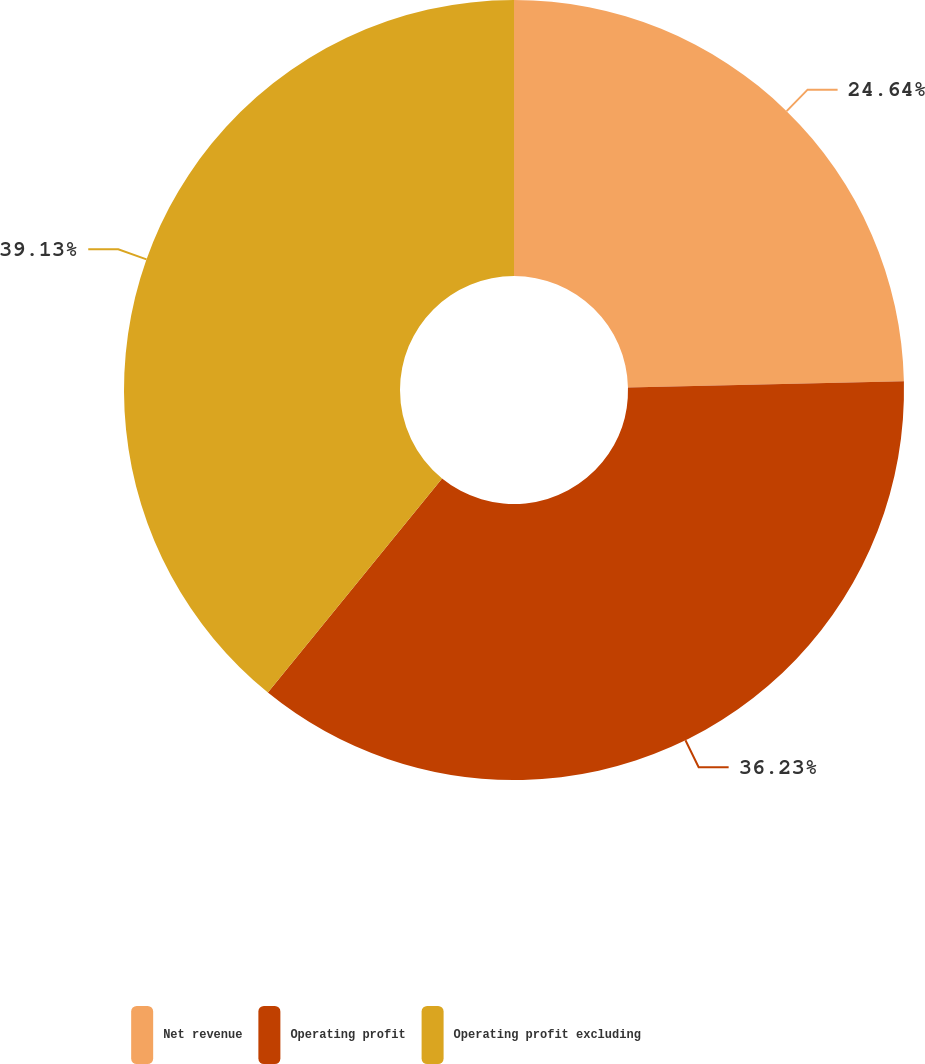Convert chart. <chart><loc_0><loc_0><loc_500><loc_500><pie_chart><fcel>Net revenue<fcel>Operating profit<fcel>Operating profit excluding<nl><fcel>24.64%<fcel>36.23%<fcel>39.13%<nl></chart> 